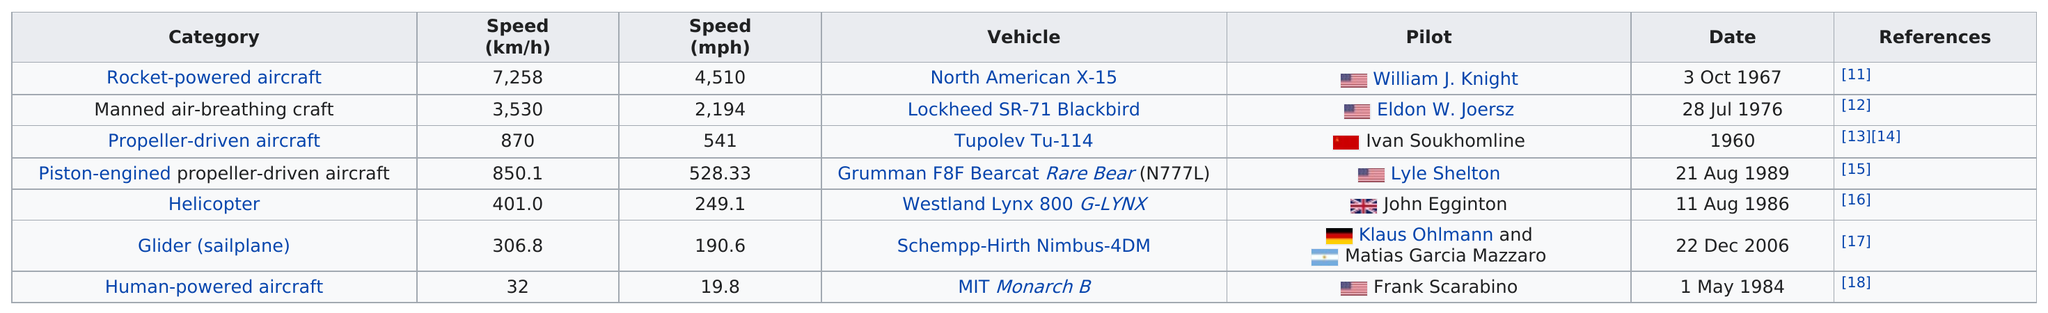Outline some significant characteristics in this image. The Tupolev Tu-114 vehicle achieved a speed of 541mph, making it a record-breaking vehicle in its time. The top speed was 4,510 miles per hour. The least fastest aircraft is the human-powered aircraft, which is powered solely by the human body. The pilot of the MIT Mitron B was Frank Scarabino. It is known that propeller-driven aircraft can travel at speeds of at least 500.00 mph, making them a viable option for high-speed travel. 